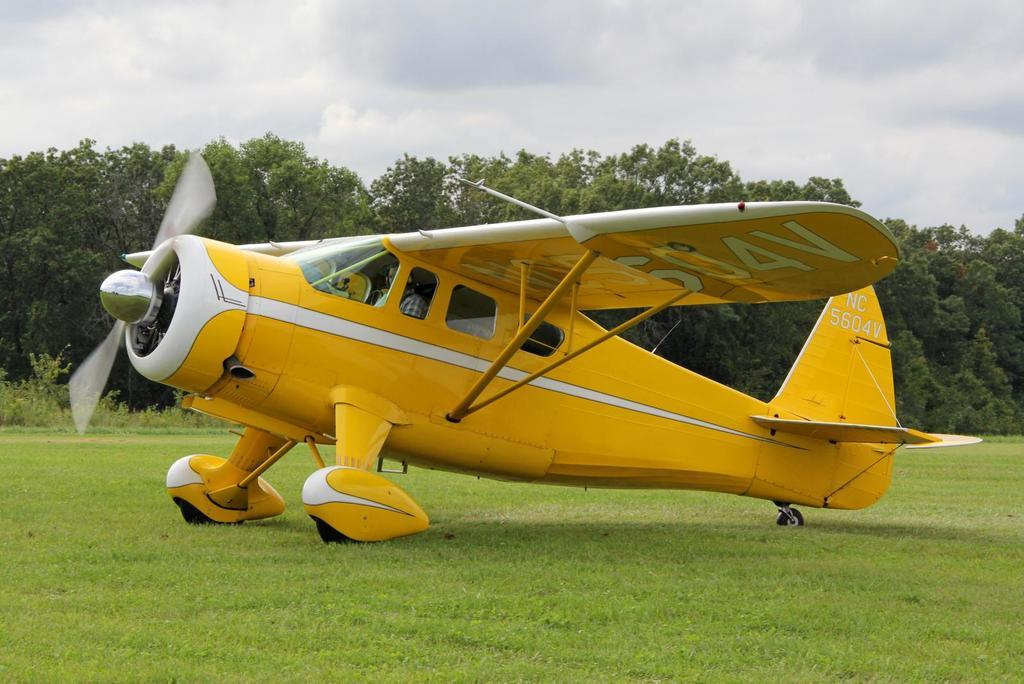Who is present in the image? There is a man in the image. What is the man doing in the image? The man is sitting in a yellow airplane. What can be seen in the background of the image? There are trees and the sky visible in the background of the image. What type of trade is being conducted in the image? There is no indication of any trade being conducted in the image; it features a man sitting in a yellow airplane with trees and the sky in the background. 